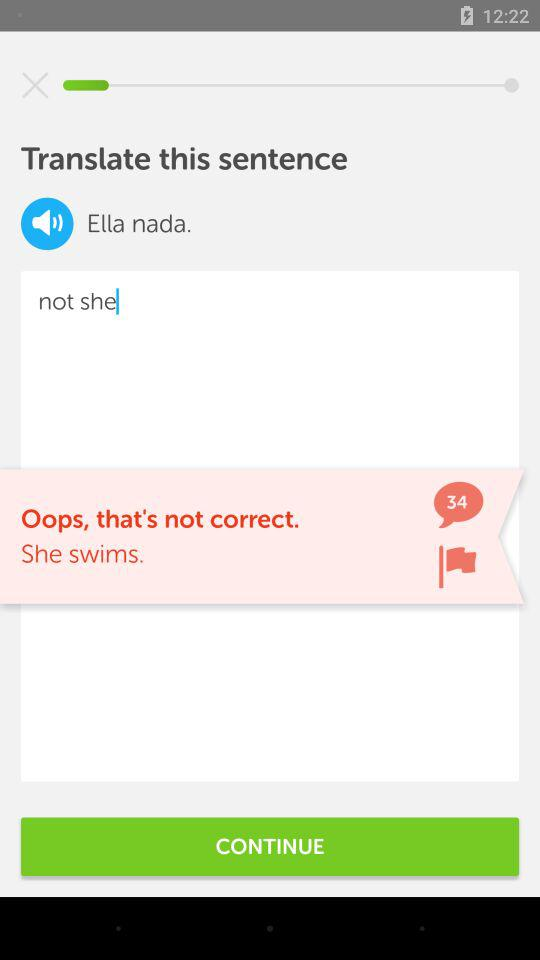Was the answer correct or incorrect? The answer was incorrect. 